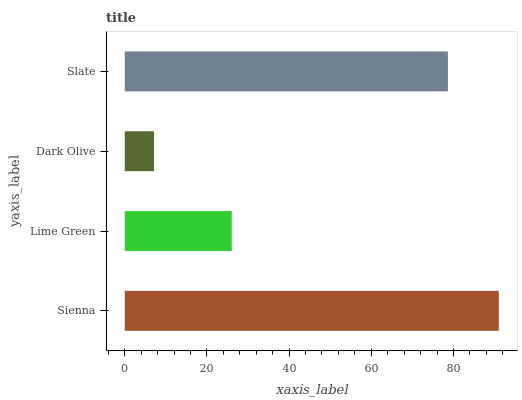Is Dark Olive the minimum?
Answer yes or no. Yes. Is Sienna the maximum?
Answer yes or no. Yes. Is Lime Green the minimum?
Answer yes or no. No. Is Lime Green the maximum?
Answer yes or no. No. Is Sienna greater than Lime Green?
Answer yes or no. Yes. Is Lime Green less than Sienna?
Answer yes or no. Yes. Is Lime Green greater than Sienna?
Answer yes or no. No. Is Sienna less than Lime Green?
Answer yes or no. No. Is Slate the high median?
Answer yes or no. Yes. Is Lime Green the low median?
Answer yes or no. Yes. Is Dark Olive the high median?
Answer yes or no. No. Is Slate the low median?
Answer yes or no. No. 